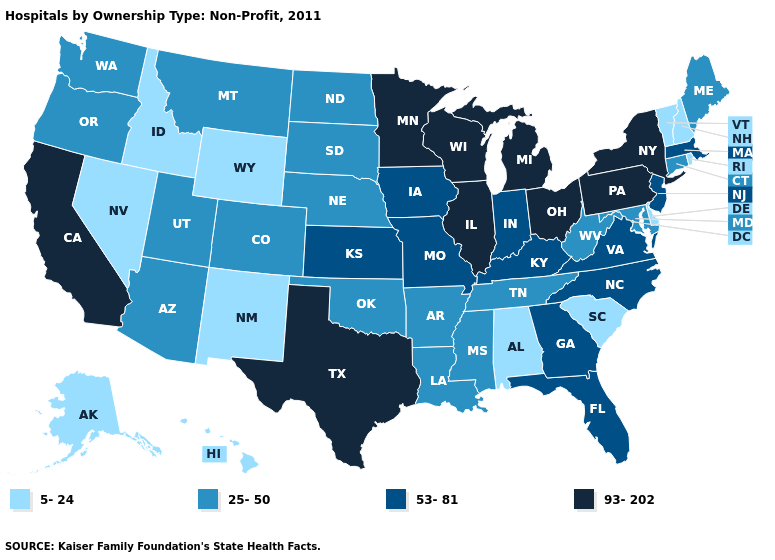Name the states that have a value in the range 5-24?
Short answer required. Alabama, Alaska, Delaware, Hawaii, Idaho, Nevada, New Hampshire, New Mexico, Rhode Island, South Carolina, Vermont, Wyoming. What is the value of Maine?
Quick response, please. 25-50. Does Pennsylvania have the highest value in the USA?
Short answer required. Yes. What is the value of Pennsylvania?
Answer briefly. 93-202. Name the states that have a value in the range 53-81?
Short answer required. Florida, Georgia, Indiana, Iowa, Kansas, Kentucky, Massachusetts, Missouri, New Jersey, North Carolina, Virginia. What is the highest value in states that border Louisiana?
Keep it brief. 93-202. Name the states that have a value in the range 53-81?
Concise answer only. Florida, Georgia, Indiana, Iowa, Kansas, Kentucky, Massachusetts, Missouri, New Jersey, North Carolina, Virginia. What is the value of Kentucky?
Be succinct. 53-81. Name the states that have a value in the range 53-81?
Give a very brief answer. Florida, Georgia, Indiana, Iowa, Kansas, Kentucky, Massachusetts, Missouri, New Jersey, North Carolina, Virginia. What is the highest value in the USA?
Keep it brief. 93-202. Which states have the highest value in the USA?
Answer briefly. California, Illinois, Michigan, Minnesota, New York, Ohio, Pennsylvania, Texas, Wisconsin. What is the highest value in states that border New York?
Write a very short answer. 93-202. Name the states that have a value in the range 25-50?
Short answer required. Arizona, Arkansas, Colorado, Connecticut, Louisiana, Maine, Maryland, Mississippi, Montana, Nebraska, North Dakota, Oklahoma, Oregon, South Dakota, Tennessee, Utah, Washington, West Virginia. Among the states that border Rhode Island , which have the lowest value?
Short answer required. Connecticut. 